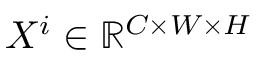Convert formula to latex. <formula><loc_0><loc_0><loc_500><loc_500>X ^ { i } \in \mathbb { R } ^ { C \times W \times H }</formula> 